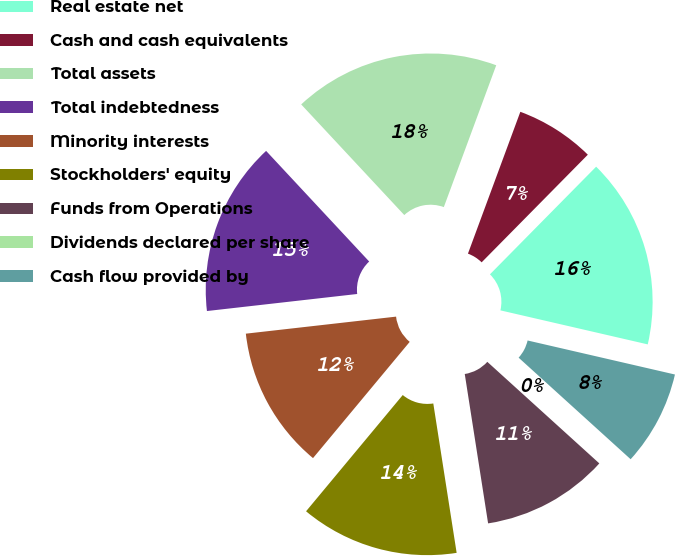<chart> <loc_0><loc_0><loc_500><loc_500><pie_chart><fcel>Real estate net<fcel>Cash and cash equivalents<fcel>Total assets<fcel>Total indebtedness<fcel>Minority interests<fcel>Stockholders' equity<fcel>Funds from Operations<fcel>Dividends declared per share<fcel>Cash flow provided by<nl><fcel>16.22%<fcel>6.76%<fcel>17.57%<fcel>14.86%<fcel>12.16%<fcel>13.51%<fcel>10.81%<fcel>0.0%<fcel>8.11%<nl></chart> 